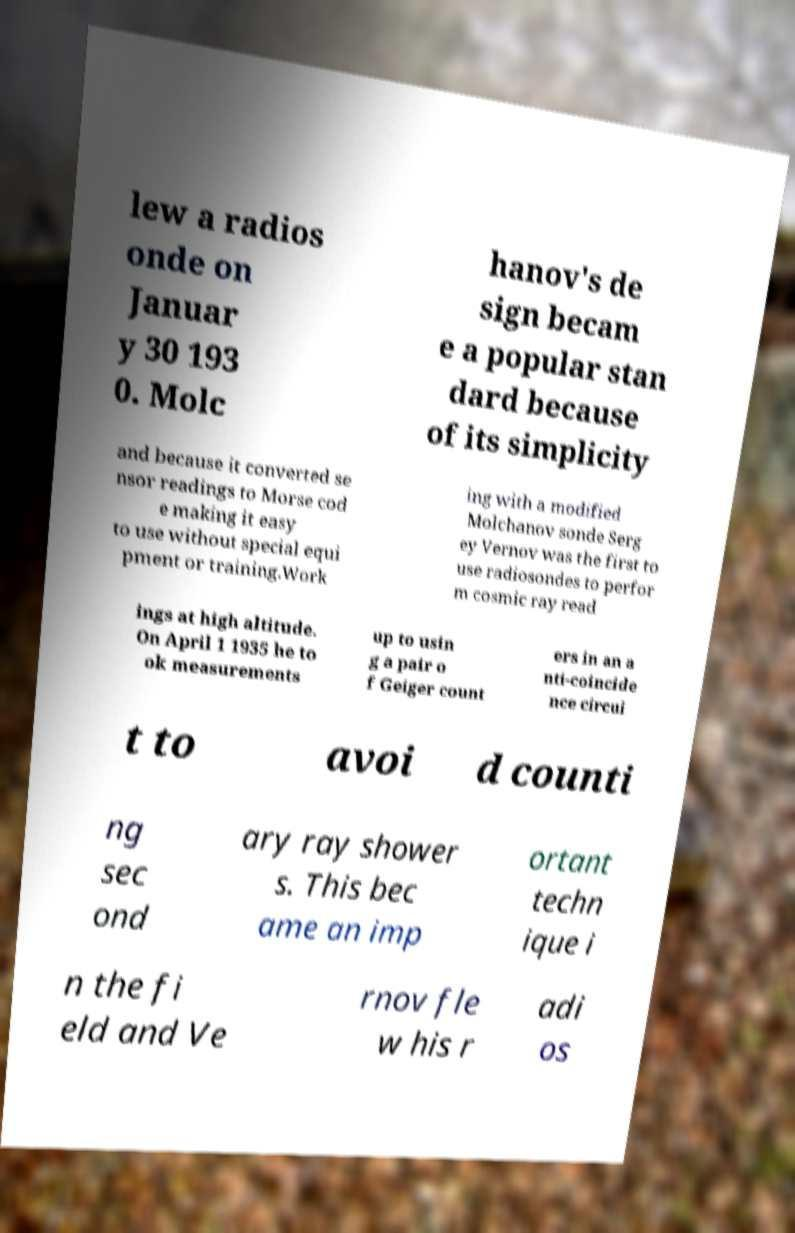Please identify and transcribe the text found in this image. lew a radios onde on Januar y 30 193 0. Molc hanov's de sign becam e a popular stan dard because of its simplicity and because it converted se nsor readings to Morse cod e making it easy to use without special equi pment or training.Work ing with a modified Molchanov sonde Serg ey Vernov was the first to use radiosondes to perfor m cosmic ray read ings at high altitude. On April 1 1935 he to ok measurements up to usin g a pair o f Geiger count ers in an a nti-coincide nce circui t to avoi d counti ng sec ond ary ray shower s. This bec ame an imp ortant techn ique i n the fi eld and Ve rnov fle w his r adi os 